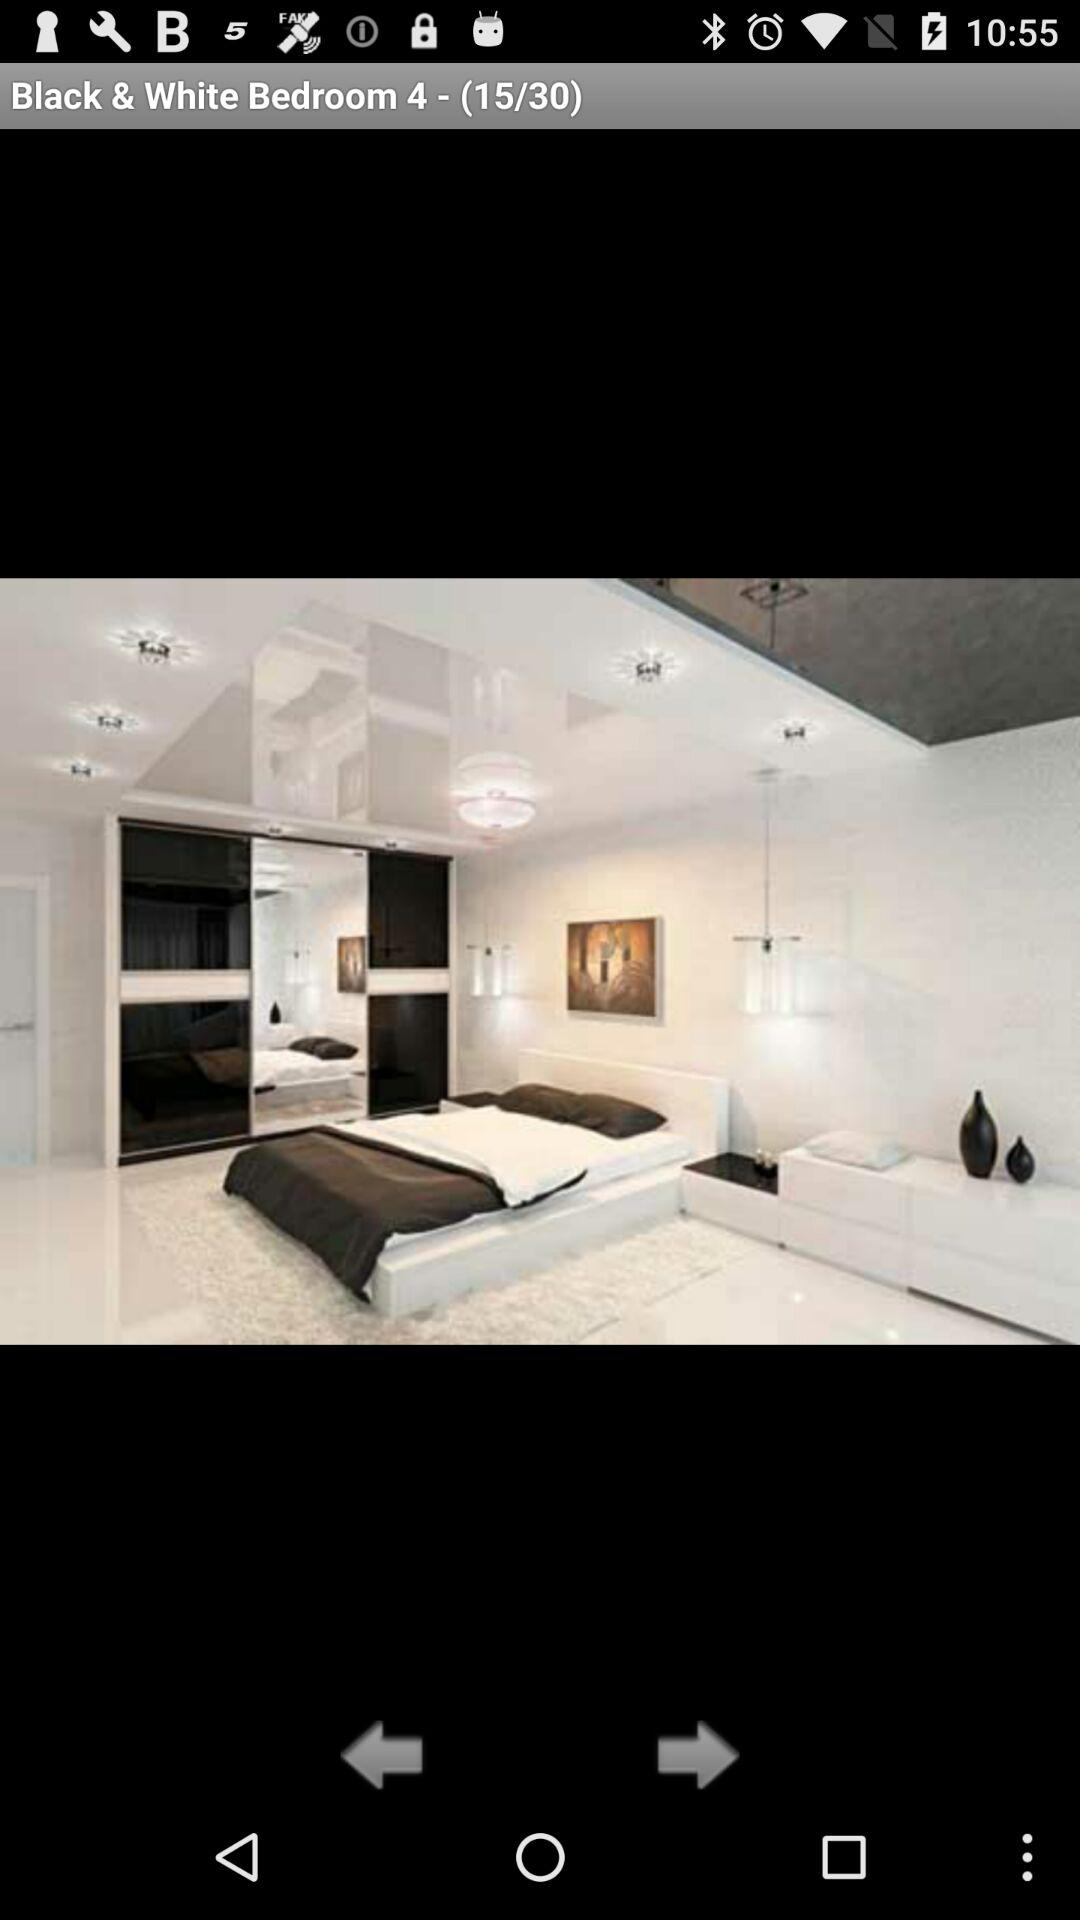What is the total number of pictures? The total number of pictures is 30. 